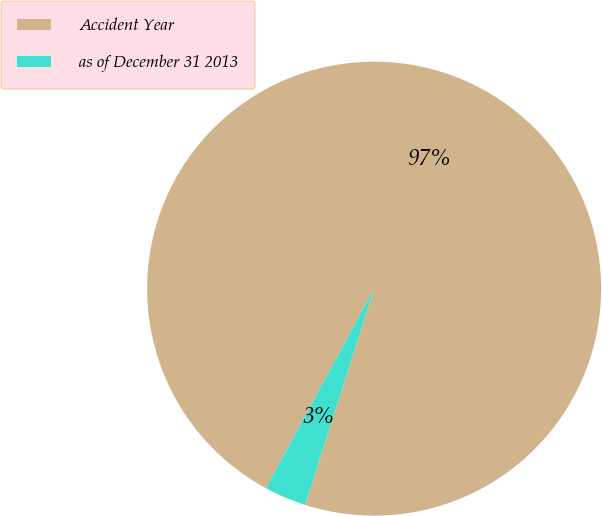Convert chart. <chart><loc_0><loc_0><loc_500><loc_500><pie_chart><fcel>Accident Year<fcel>as of December 31 2013<nl><fcel>97.01%<fcel>2.99%<nl></chart> 